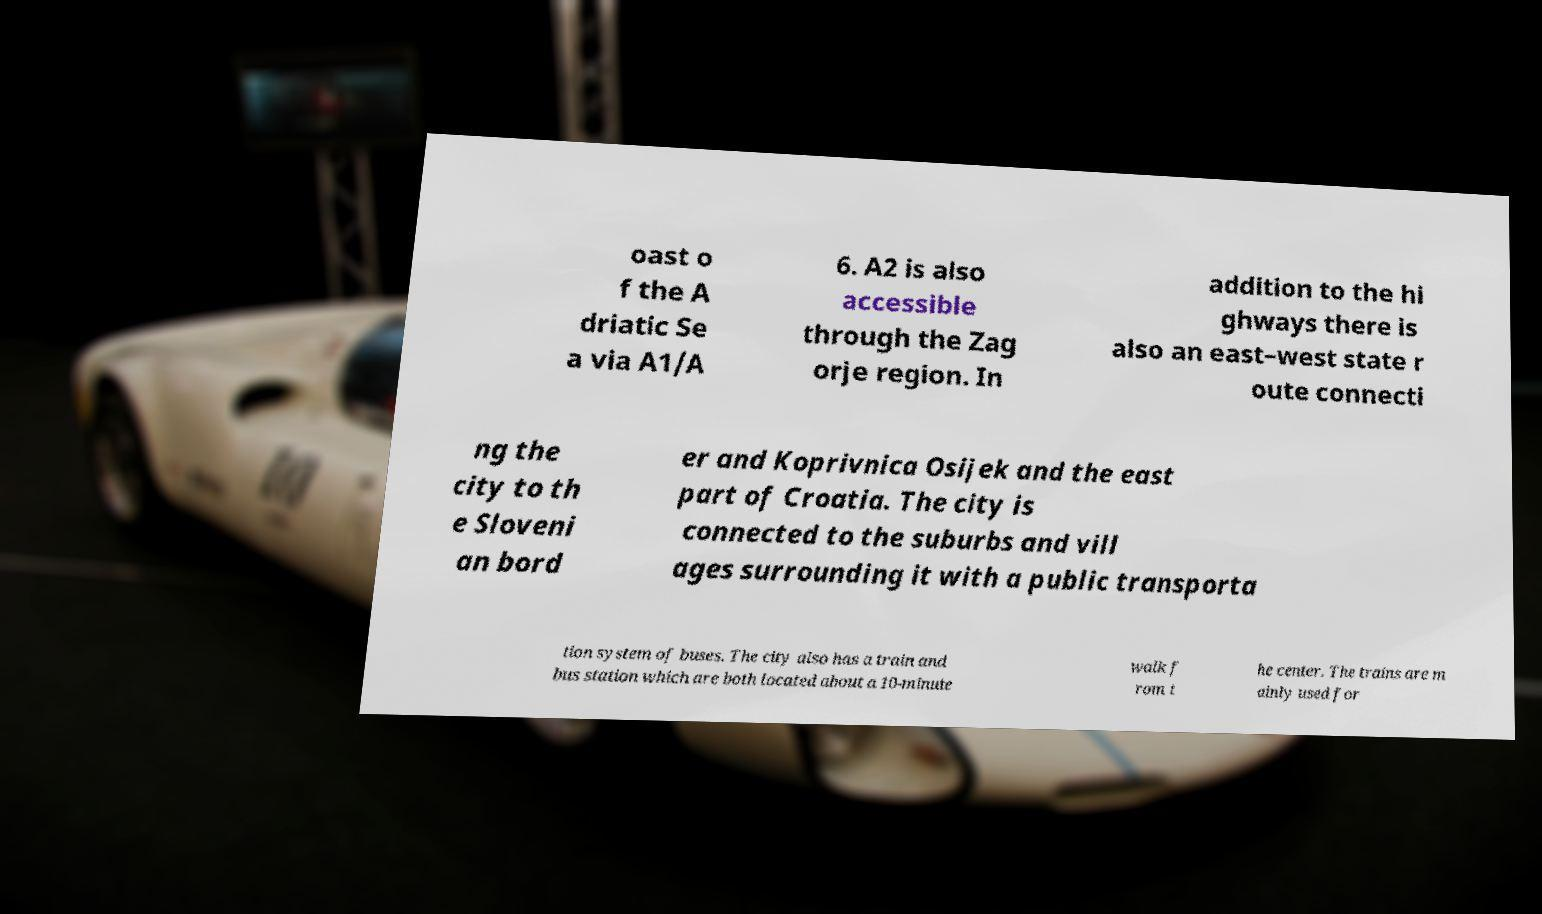I need the written content from this picture converted into text. Can you do that? oast o f the A driatic Se a via A1/A 6. A2 is also accessible through the Zag orje region. In addition to the hi ghways there is also an east–west state r oute connecti ng the city to th e Sloveni an bord er and Koprivnica Osijek and the east part of Croatia. The city is connected to the suburbs and vill ages surrounding it with a public transporta tion system of buses. The city also has a train and bus station which are both located about a 10-minute walk f rom t he center. The trains are m ainly used for 